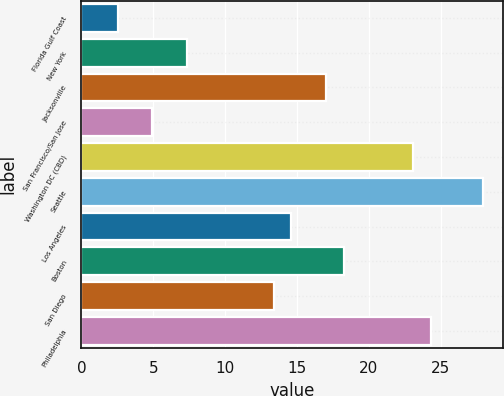Convert chart. <chart><loc_0><loc_0><loc_500><loc_500><bar_chart><fcel>Florida Gulf Coast<fcel>New York<fcel>Jacksonville<fcel>San Francisco/San Jose<fcel>Washington DC (CBD)<fcel>Seattle<fcel>Los Angeles<fcel>Boston<fcel>San Diego<fcel>Philadelphia<nl><fcel>2.52<fcel>7.36<fcel>17.04<fcel>4.94<fcel>23.09<fcel>27.93<fcel>14.62<fcel>18.25<fcel>13.41<fcel>24.3<nl></chart> 